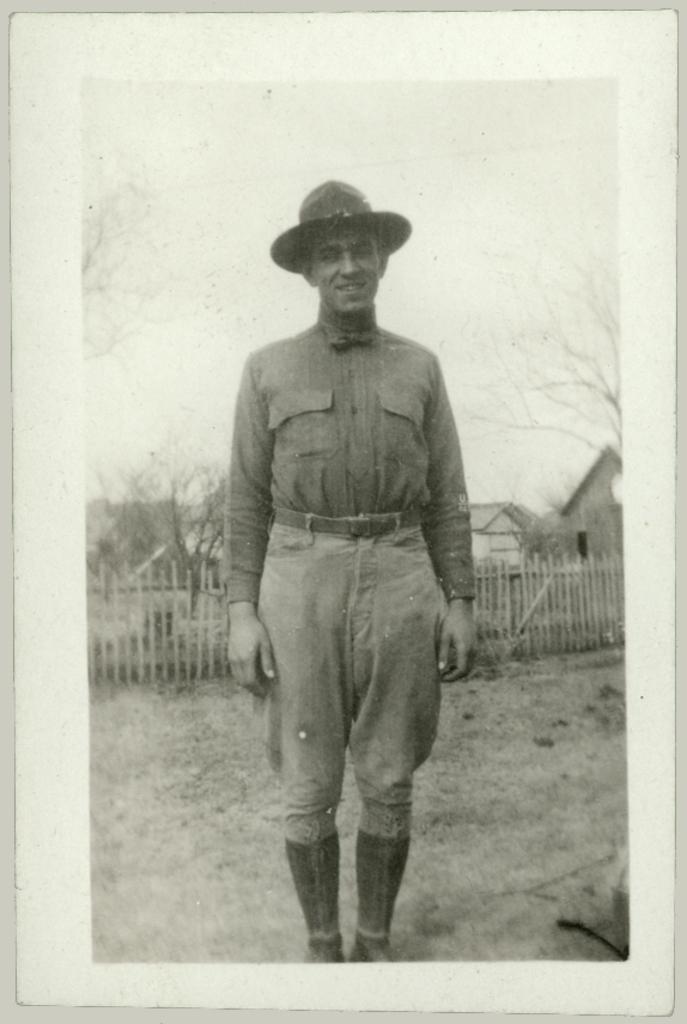Describe this image in one or two sentences. We can see photo,in this photo we can see a man standing and wore hat. Background we can see fencehouses,trees and sky. 